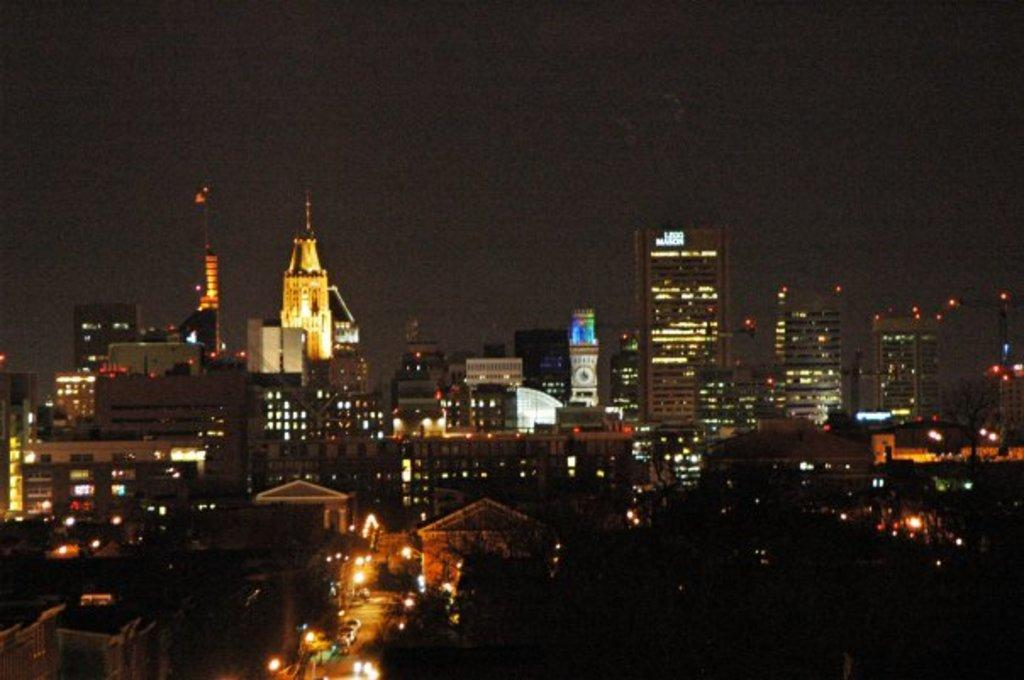What type of structures can be seen in the image? There are houses and buildings in the image. Are there any illuminated objects in the image? Yes, there are lights in the image. What other tall structures can be seen in the image? There are towers in the image. What mode of transportation is visible in the image? There are fleets of vehicles on the road in the image. What type of vegetation is present in the image? There are trees in the image. What part of the environment is visible in the image? The sky is visible in the image. Based on the presence of lights and the absence of sunlight, can you infer the time of day the image was taken? Yes, the image is likely taken during the night. What type of summer activity is taking place in the image? The image does not depict any summer activities, as it is likely taken during the night and focuses on structures, lights, and vehicles. What is the top-most feature of the house in the image? There is no specific house mentioned in the provided facts, so it is impossible to determine the top-most feature of a house in the image. 